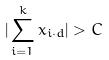Convert formula to latex. <formula><loc_0><loc_0><loc_500><loc_500>| \sum _ { i = 1 } ^ { k } x _ { i \cdot d } | > C</formula> 